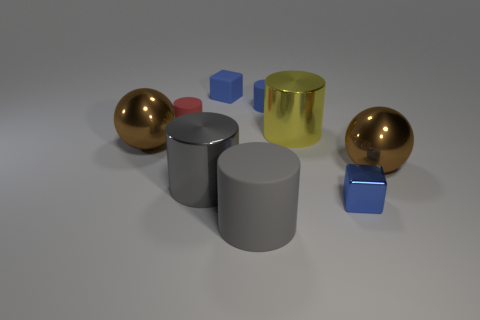How many blue things are small metallic cylinders or small objects?
Your answer should be compact. 3. There is a cylinder that is the same color as the big rubber object; what size is it?
Make the answer very short. Large. Is the number of rubber objects greater than the number of large green shiny cubes?
Keep it short and to the point. Yes. Is the color of the tiny metallic cube the same as the large matte object?
Your answer should be compact. No. How many objects are red objects or matte cylinders that are behind the yellow shiny cylinder?
Your answer should be compact. 2. What number of other things are the same shape as the small metallic thing?
Ensure brevity in your answer.  1. Are there fewer red cylinders that are in front of the yellow shiny thing than large metal cylinders that are in front of the gray matte thing?
Keep it short and to the point. No. Is there anything else that is the same material as the yellow object?
Offer a terse response. Yes. What shape is the large object that is made of the same material as the red cylinder?
Your response must be concise. Cylinder. Are there any other things that have the same color as the large rubber cylinder?
Ensure brevity in your answer.  Yes. 